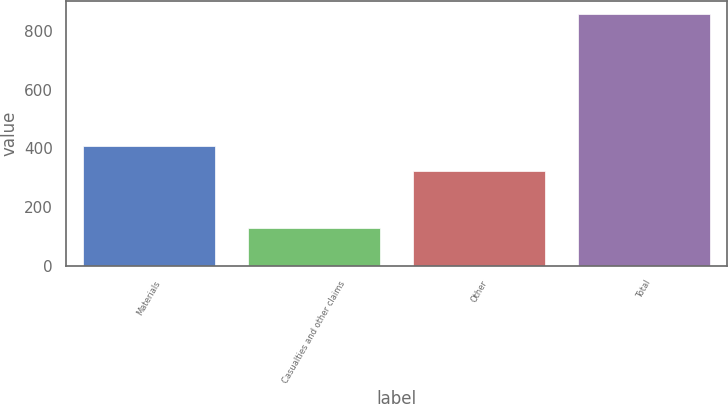Convert chart to OTSL. <chart><loc_0><loc_0><loc_500><loc_500><bar_chart><fcel>Materials<fcel>Casualties and other claims<fcel>Other<fcel>Total<nl><fcel>408<fcel>130<fcel>321<fcel>859<nl></chart> 